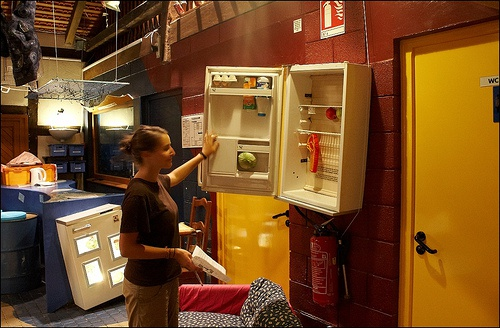Describe the objects in this image and their specific colors. I can see refrigerator in black, olive, tan, and maroon tones, people in black, maroon, and brown tones, couch in black, maroon, and gray tones, chair in black, maroon, and brown tones, and bottle in black, olive, and khaki tones in this image. 